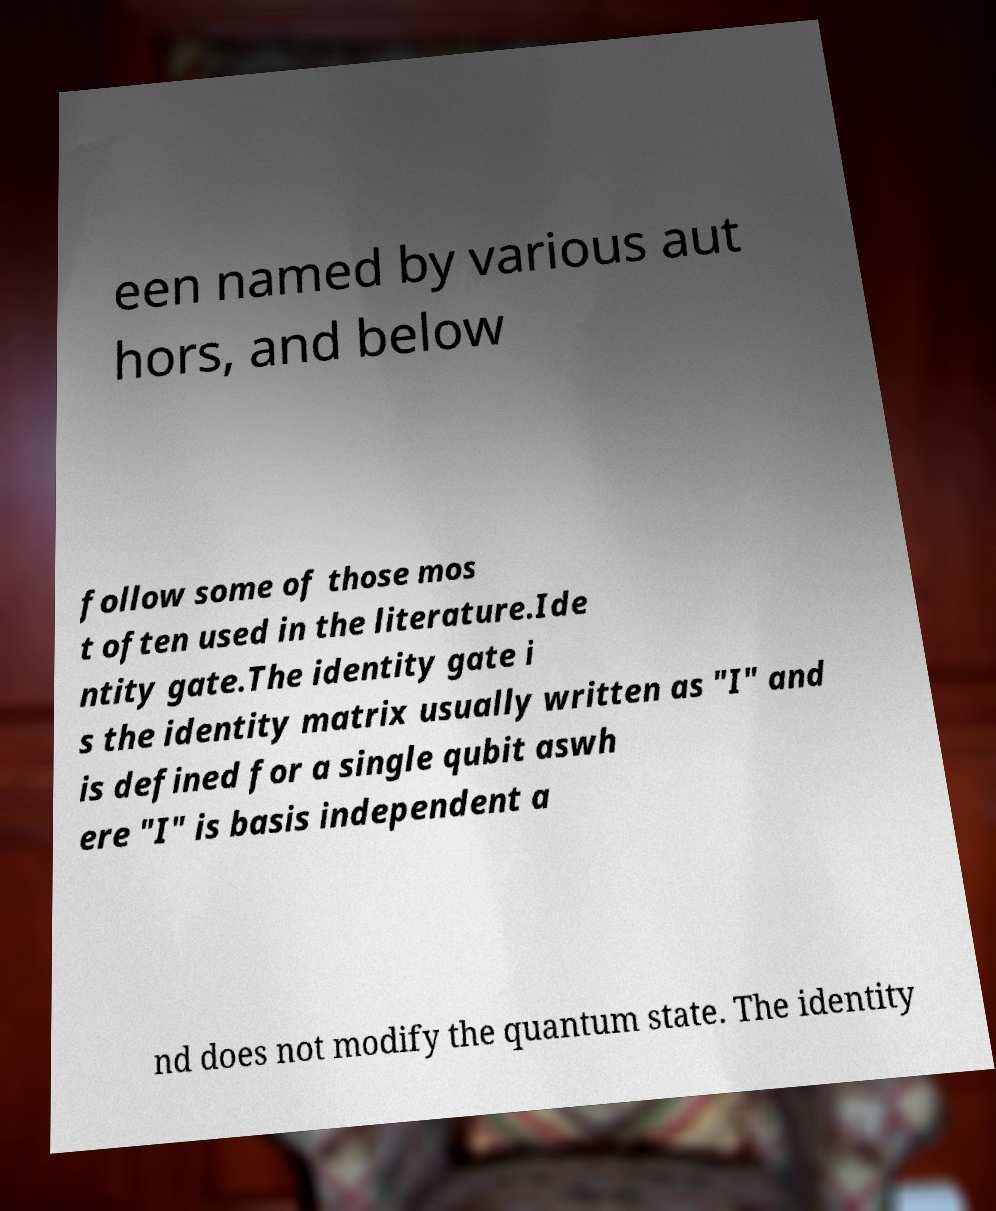Please identify and transcribe the text found in this image. een named by various aut hors, and below follow some of those mos t often used in the literature.Ide ntity gate.The identity gate i s the identity matrix usually written as "I" and is defined for a single qubit aswh ere "I" is basis independent a nd does not modify the quantum state. The identity 